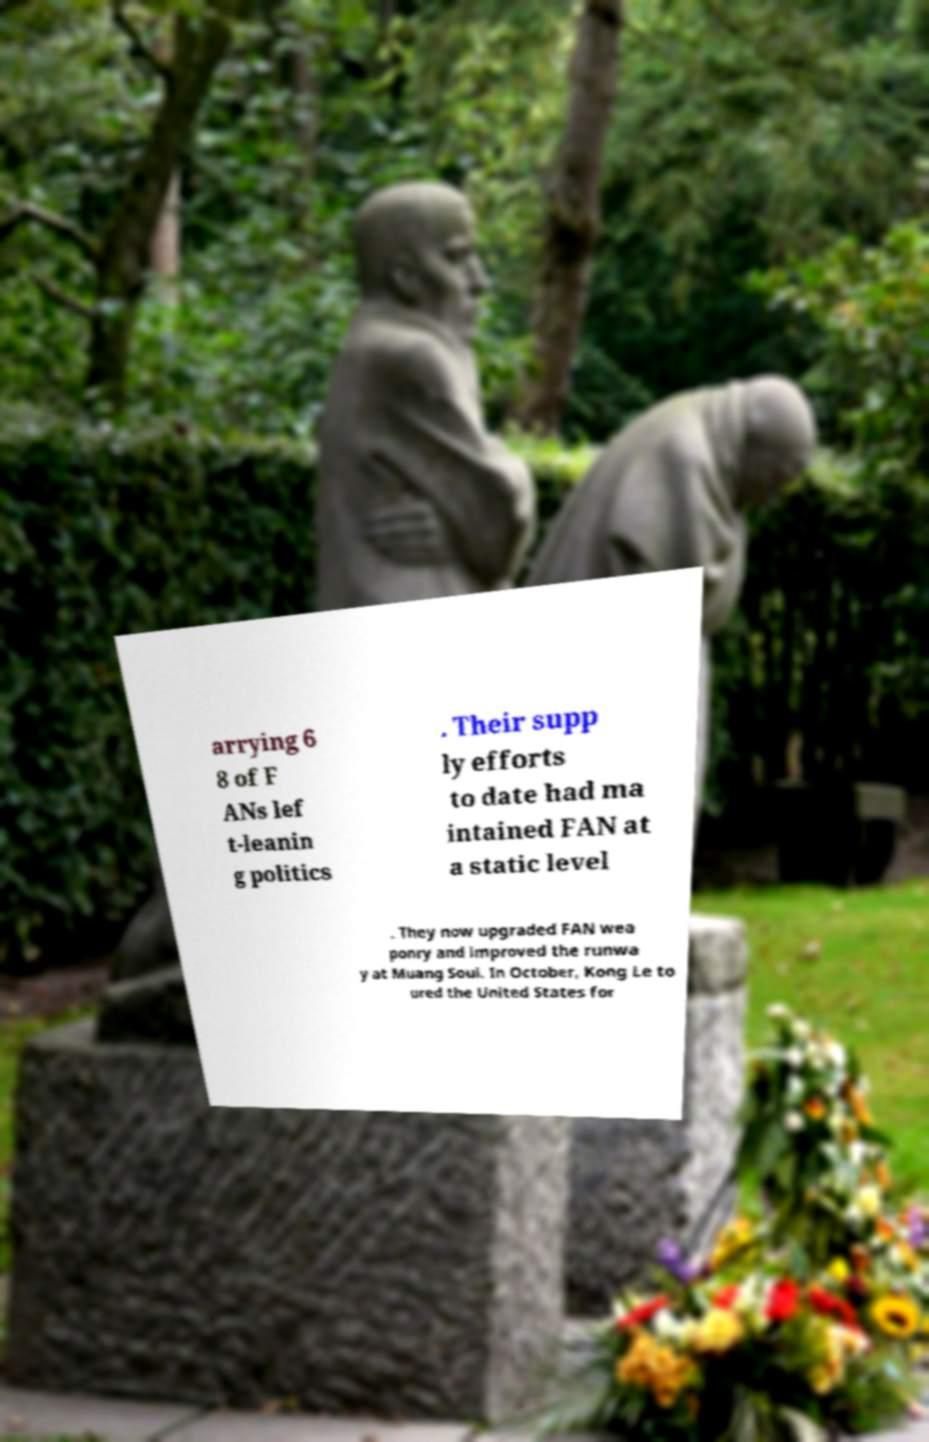Please read and relay the text visible in this image. What does it say? arrying 6 8 of F ANs lef t-leanin g politics . Their supp ly efforts to date had ma intained FAN at a static level . They now upgraded FAN wea ponry and improved the runwa y at Muang Soui. In October, Kong Le to ured the United States for 